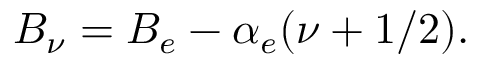Convert formula to latex. <formula><loc_0><loc_0><loc_500><loc_500>B _ { \nu } = B _ { e } - \alpha _ { e } ( \nu + 1 / 2 ) .</formula> 